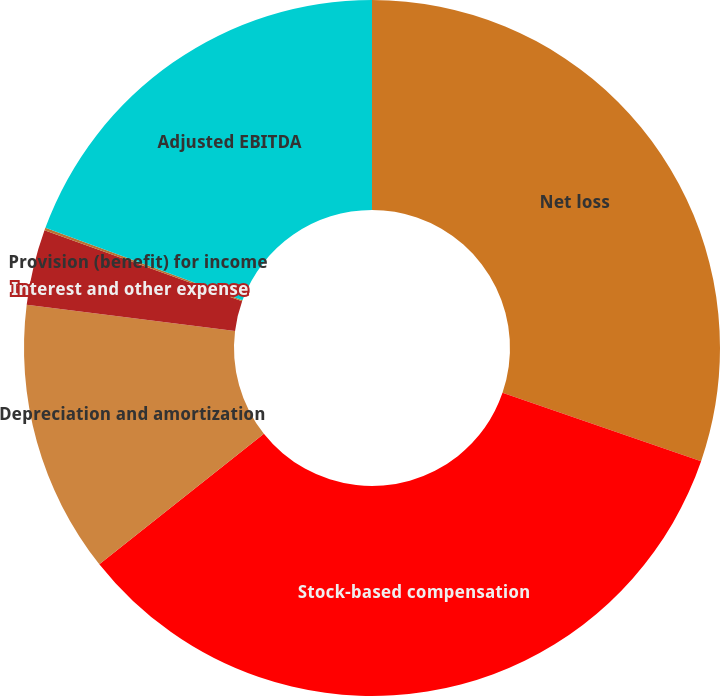Convert chart to OTSL. <chart><loc_0><loc_0><loc_500><loc_500><pie_chart><fcel>Net loss<fcel>Stock-based compensation<fcel>Depreciation and amortization<fcel>Interest and other expense<fcel>Provision (benefit) for income<fcel>Adjusted EBITDA<nl><fcel>30.27%<fcel>34.06%<fcel>12.65%<fcel>3.51%<fcel>0.12%<fcel>19.39%<nl></chart> 